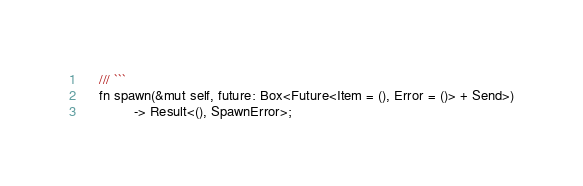Convert code to text. <code><loc_0><loc_0><loc_500><loc_500><_Rust_>    /// ```
    fn spawn(&mut self, future: Box<Future<Item = (), Error = ()> + Send>)
             -> Result<(), SpawnError>;
</code> 